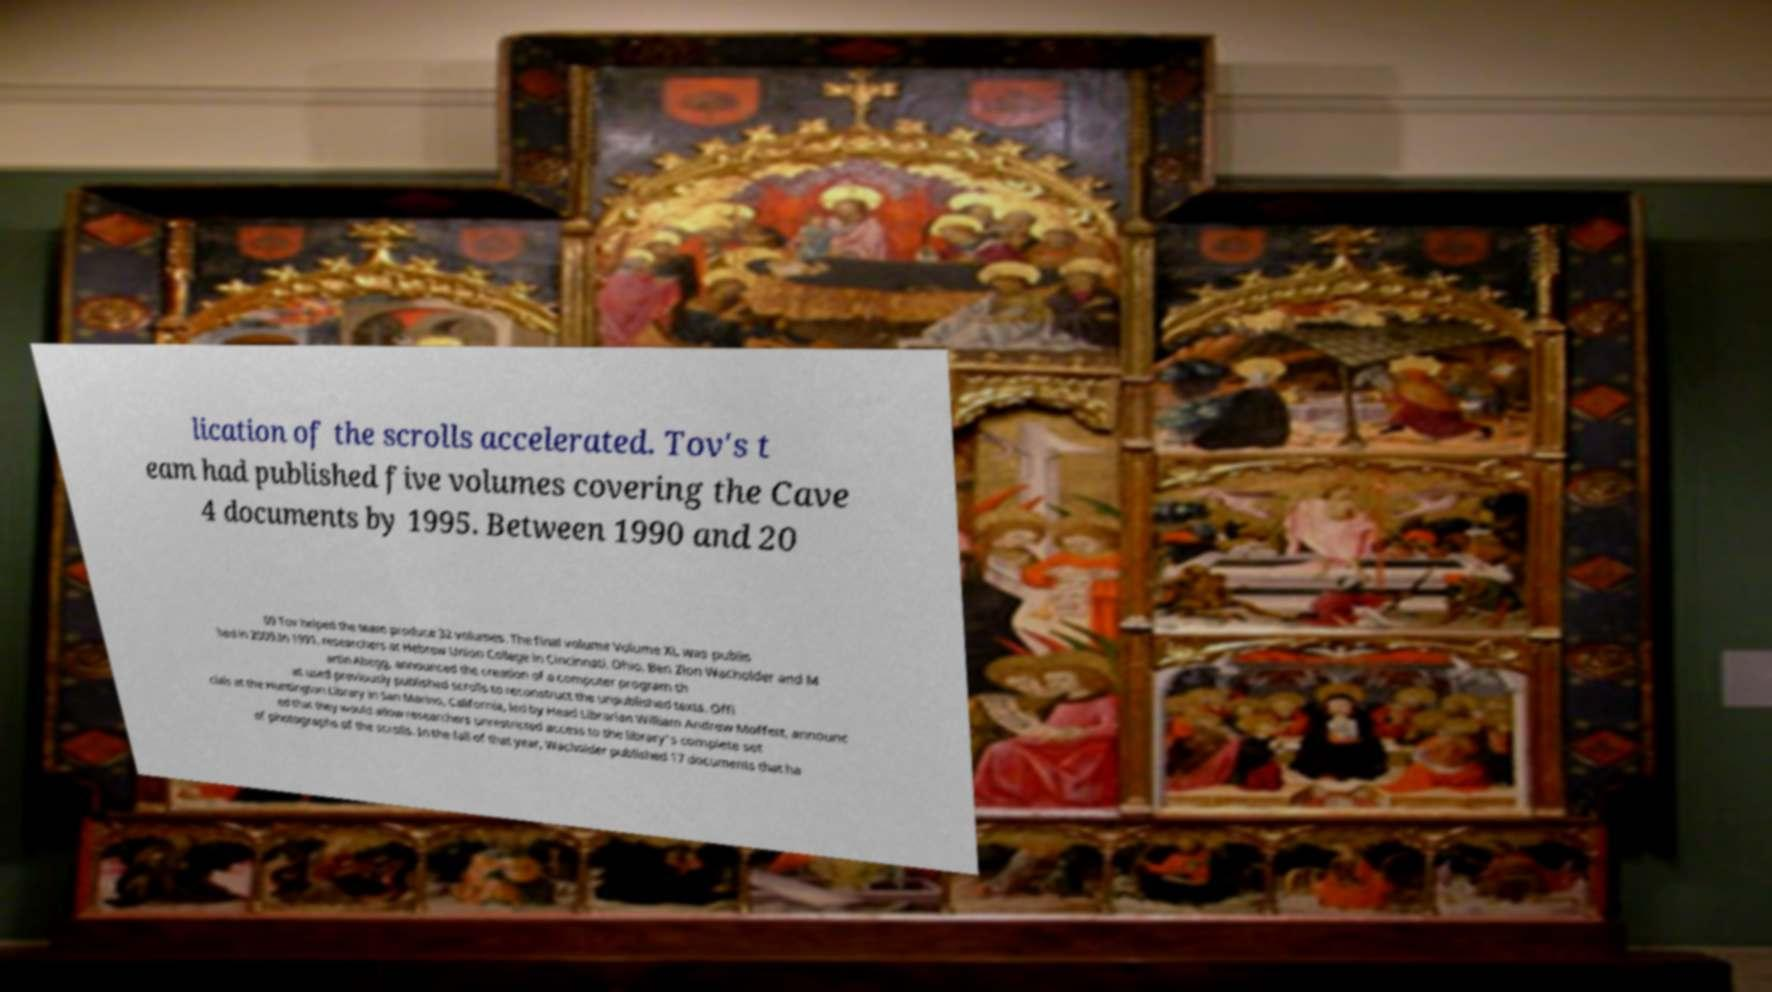Can you read and provide the text displayed in the image?This photo seems to have some interesting text. Can you extract and type it out for me? lication of the scrolls accelerated. Tov's t eam had published five volumes covering the Cave 4 documents by 1995. Between 1990 and 20 09 Tov helped the team produce 32 volumes. The final volume Volume XL was publis hed in 2009.In 1991, researchers at Hebrew Union College in Cincinnati, Ohio, Ben Zion Wacholder and M artin Abegg, announced the creation of a computer program th at used previously published scrolls to reconstruct the unpublished texts. Offi cials at the Huntington Library in San Marino, California, led by Head Librarian William Andrew Moffett, announc ed that they would allow researchers unrestricted access to the library's complete set of photographs of the scrolls. In the fall of that year, Wacholder published 17 documents that ha 